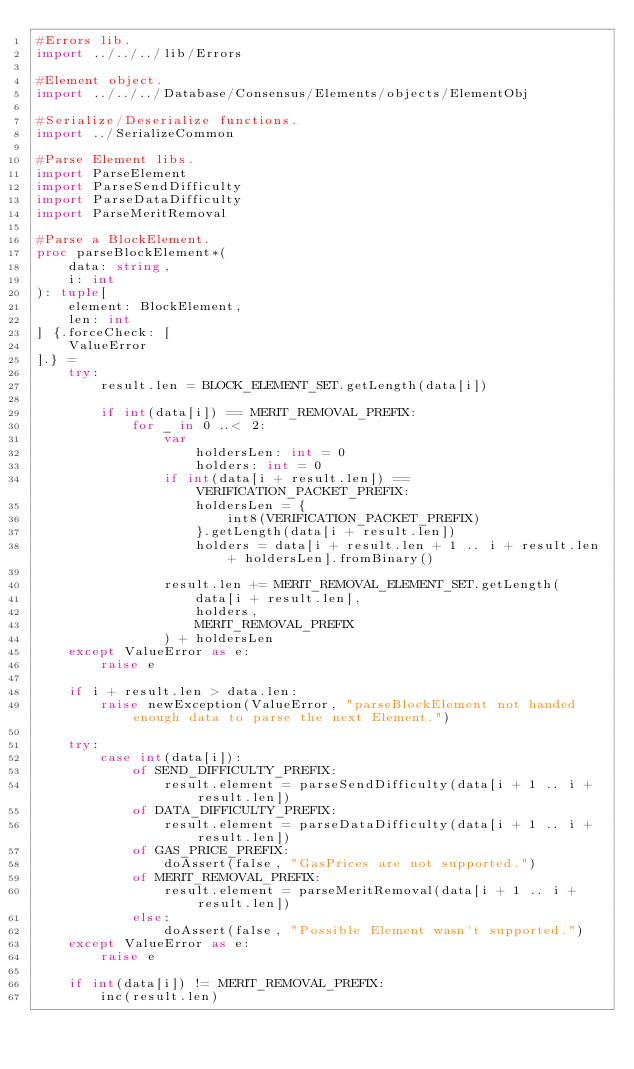<code> <loc_0><loc_0><loc_500><loc_500><_Nim_>#Errors lib.
import ../../../lib/Errors

#Element object.
import ../../../Database/Consensus/Elements/objects/ElementObj

#Serialize/Deserialize functions.
import ../SerializeCommon

#Parse Element libs.
import ParseElement
import ParseSendDifficulty
import ParseDataDifficulty
import ParseMeritRemoval

#Parse a BlockElement.
proc parseBlockElement*(
    data: string,
    i: int
): tuple[
    element: BlockElement,
    len: int
] {.forceCheck: [
    ValueError
].} =
    try:
        result.len = BLOCK_ELEMENT_SET.getLength(data[i])

        if int(data[i]) == MERIT_REMOVAL_PREFIX:
            for _ in 0 ..< 2:
                var
                    holdersLen: int = 0
                    holders: int = 0
                if int(data[i + result.len]) == VERIFICATION_PACKET_PREFIX:
                    holdersLen = {
                        int8(VERIFICATION_PACKET_PREFIX)
                    }.getLength(data[i + result.len])
                    holders = data[i + result.len + 1 .. i + result.len + holdersLen].fromBinary()

                result.len += MERIT_REMOVAL_ELEMENT_SET.getLength(
                    data[i + result.len],
                    holders,
                    MERIT_REMOVAL_PREFIX
                ) + holdersLen
    except ValueError as e:
        raise e

    if i + result.len > data.len:
        raise newException(ValueError, "parseBlockElement not handed enough data to parse the next Element.")

    try:
        case int(data[i]):
            of SEND_DIFFICULTY_PREFIX:
                result.element = parseSendDifficulty(data[i + 1 .. i + result.len])
            of DATA_DIFFICULTY_PREFIX:
                result.element = parseDataDifficulty(data[i + 1 .. i + result.len])
            of GAS_PRICE_PREFIX:
                doAssert(false, "GasPrices are not supported.")
            of MERIT_REMOVAL_PREFIX:
                result.element = parseMeritRemoval(data[i + 1 .. i + result.len])
            else:
                doAssert(false, "Possible Element wasn't supported.")
    except ValueError as e:
        raise e

    if int(data[i]) != MERIT_REMOVAL_PREFIX:
        inc(result.len)
</code> 